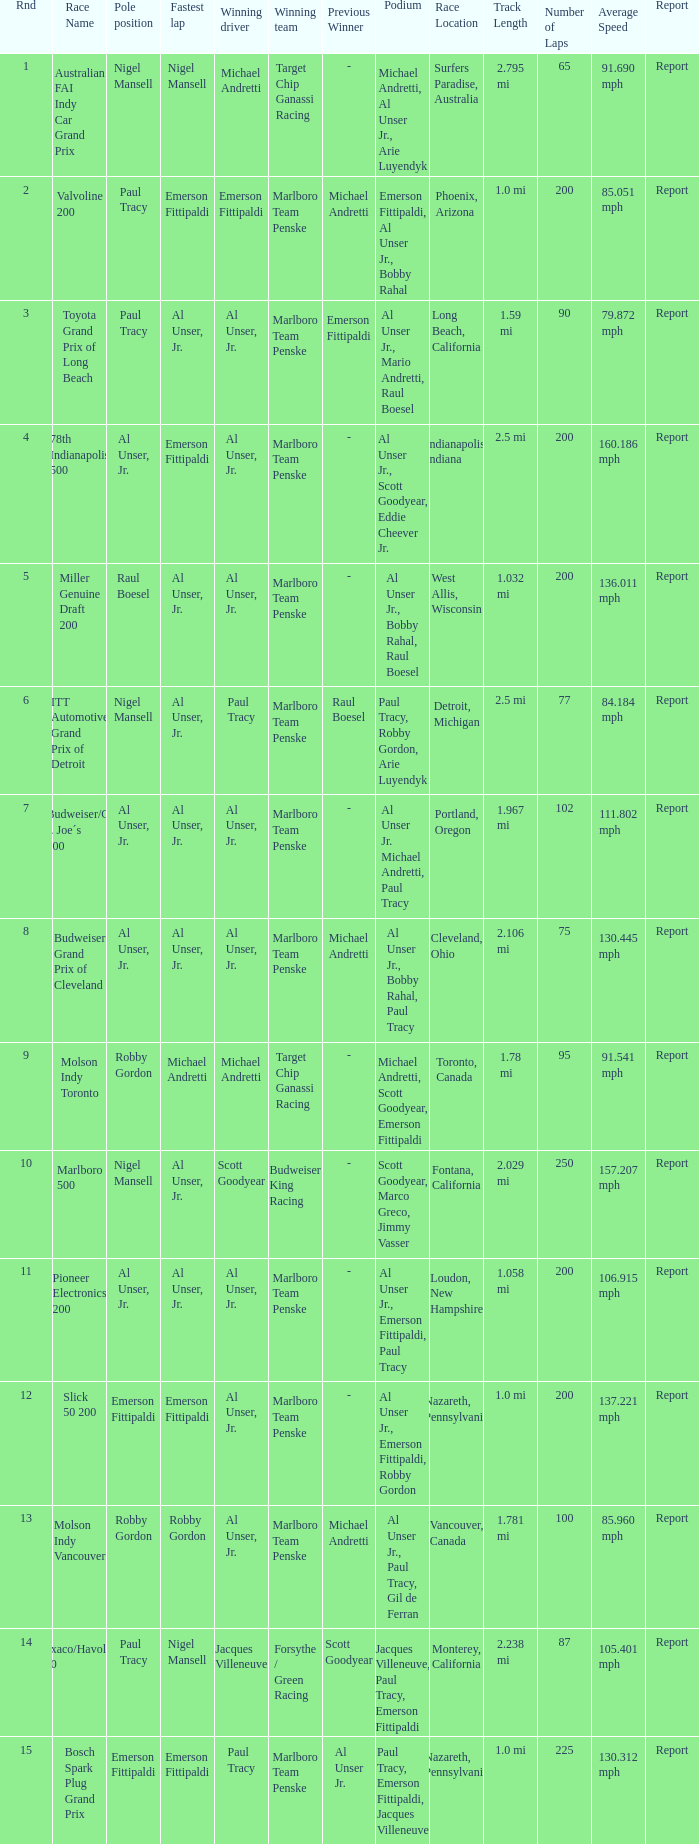What's the report of the race won by Michael Andretti, with Nigel Mansell driving the fastest lap? Report. 